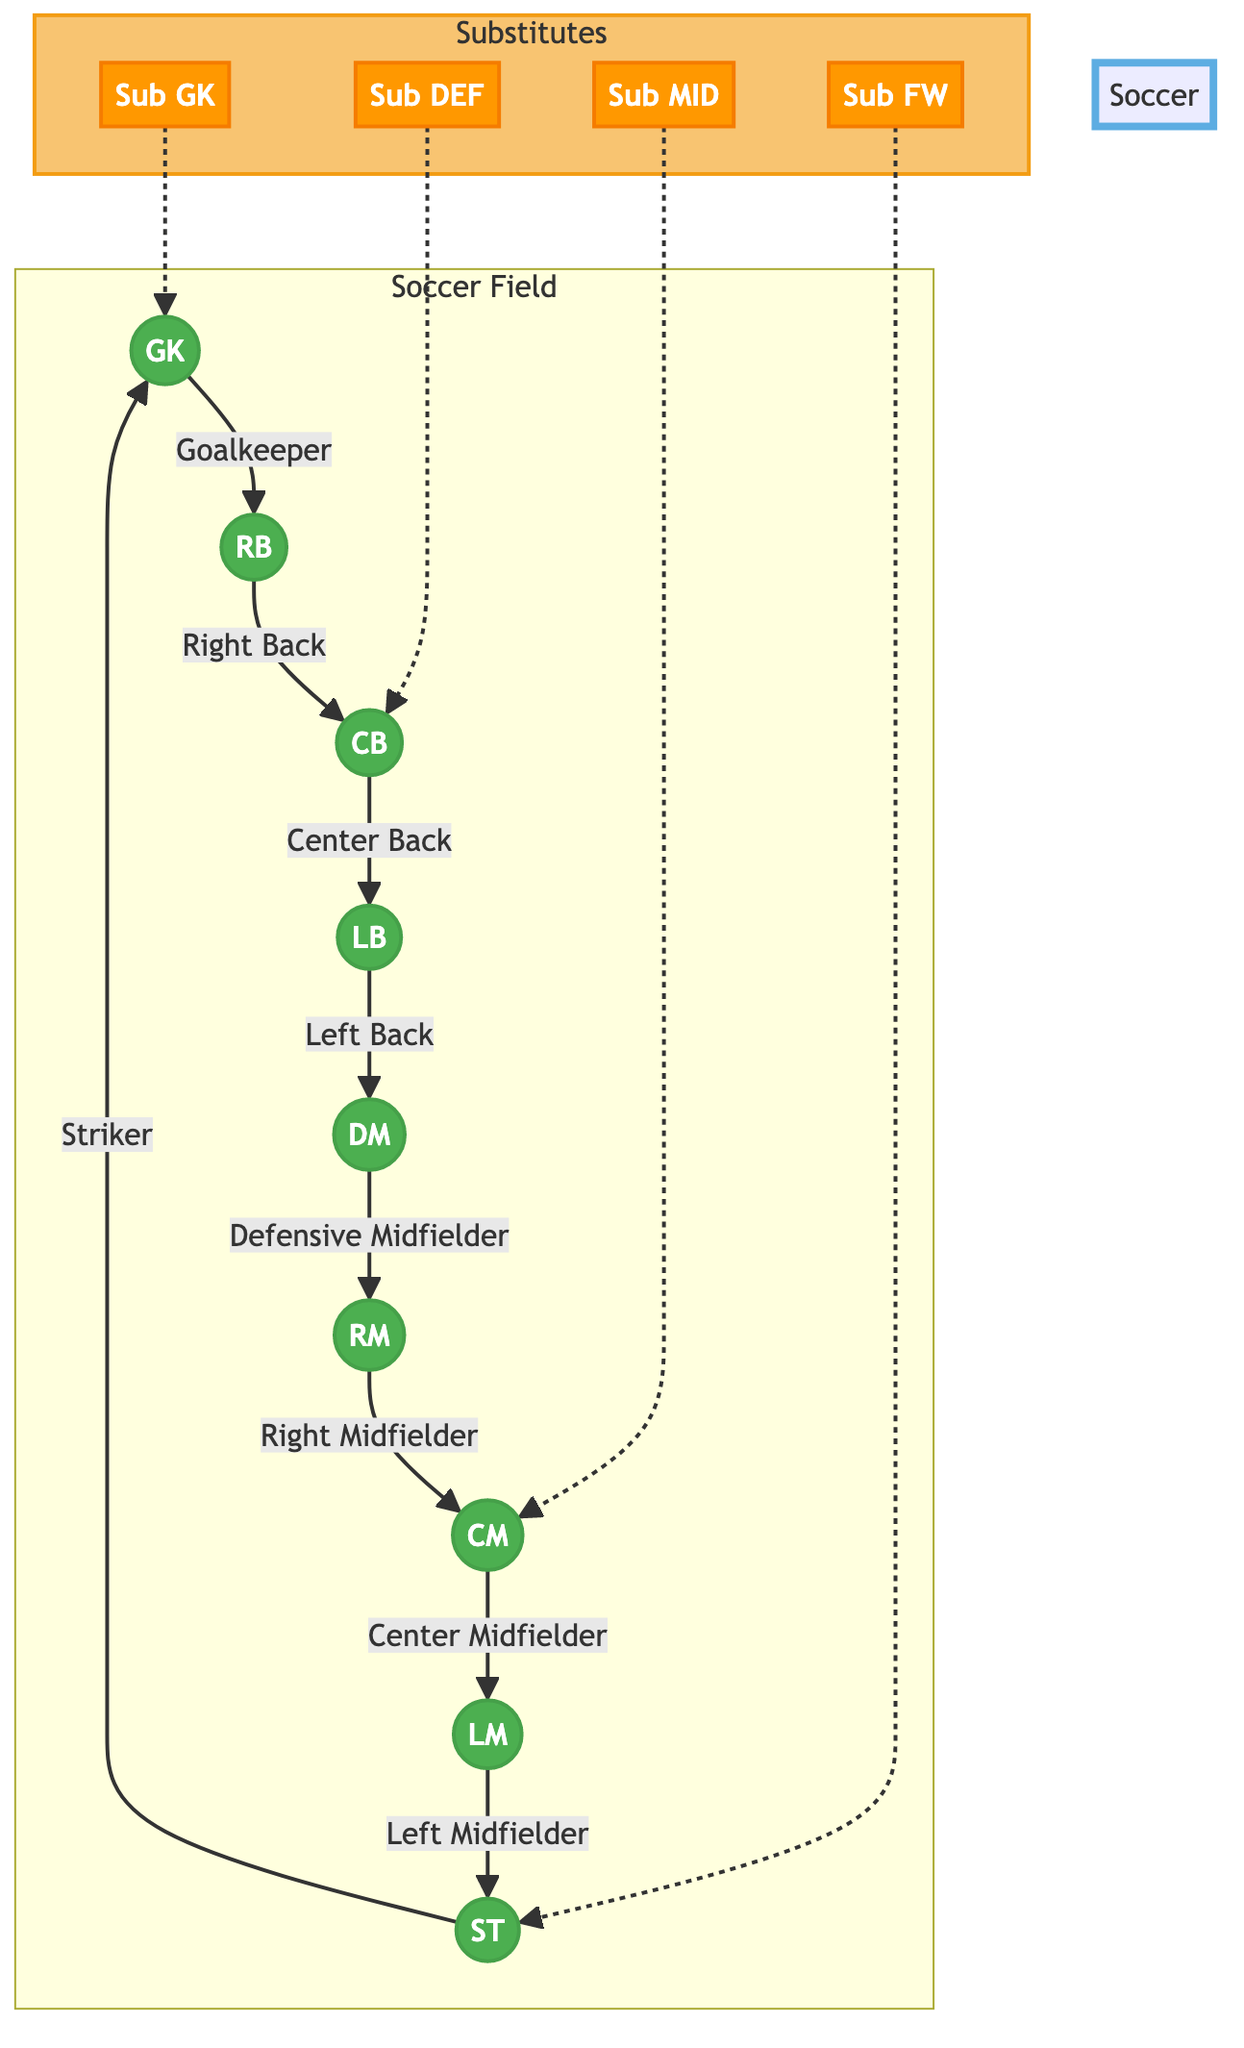What is the total number of player positions in the diagram? The diagram shows 8 main player positions: GK, RB, CB, LB, DM, RM, CM, and LM, plus one forward position (ST), which totals to 9.
Answer: 9 Which position is directly connected to the Defensive Midfielder? The Defensive Midfielder (DM) is directly connected to the Right Midfielder (RM), as shown in the diagram by the arrow pointing from DM to RM.
Answer: Right Midfielder What type of player is positioned directly opposite to the Striker? The diagram shows the Striker (ST) positioned directly opposite to the Goalkeeper (GK), indicating their roles in relation to the field layout.
Answer: Goalkeeper How many substitute positions are represented in the diagram? The diagram includes 4 substitute positions indicated: Sub GK, Sub DEF, Sub MID, and Sub FW, which totals to 4 substitutes.
Answer: 4 Which player position does the Right Back connect to? The Right Back (RB) connects to the Center Back (CB) in the diagram, illustrating the flow of player positioning.
Answer: Center Back If the Center Back is substituted, who is the designated substitute? The designated substitute for the Center Back (CB) in the diagram is marked as Sub DEF, indicating the specific substitute available for that position.
Answer: Sub DEF What visual cue distinguishes substitute positions from player positions? Substitute positions are visually distinguished by their orange color fill and different stroke style, setting them apart from the green-filled main player positions in the diagram.
Answer: Color fill (orange) Which position serves as both a starting player and the last position connected in the diagram? The Striker (ST) serves as both a starting player and is the last position connected in the diagram, as shown by the direction of the arrows connecting it back to the Goalkeeper (GK).
Answer: Striker What is the connection relationship between the Center Midfielder and the Left Midfielder? The Center Midfielder (CM) is connected to the Left Midfielder (LM) as indicated by the directed arrow from CM to LM, showing their direct positional relationship on the field.
Answer: Connected 